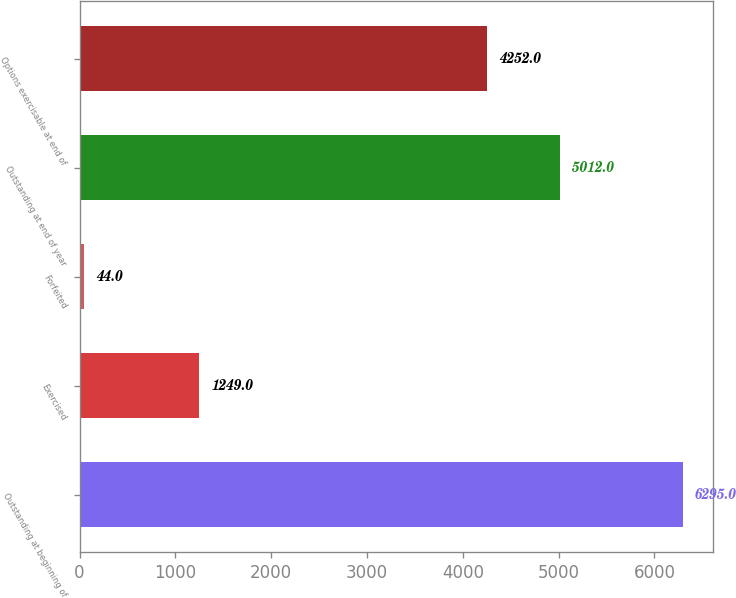<chart> <loc_0><loc_0><loc_500><loc_500><bar_chart><fcel>Outstanding at beginning of<fcel>Exercised<fcel>Forfeited<fcel>Outstanding at end of year<fcel>Options exercisable at end of<nl><fcel>6295<fcel>1249<fcel>44<fcel>5012<fcel>4252<nl></chart> 